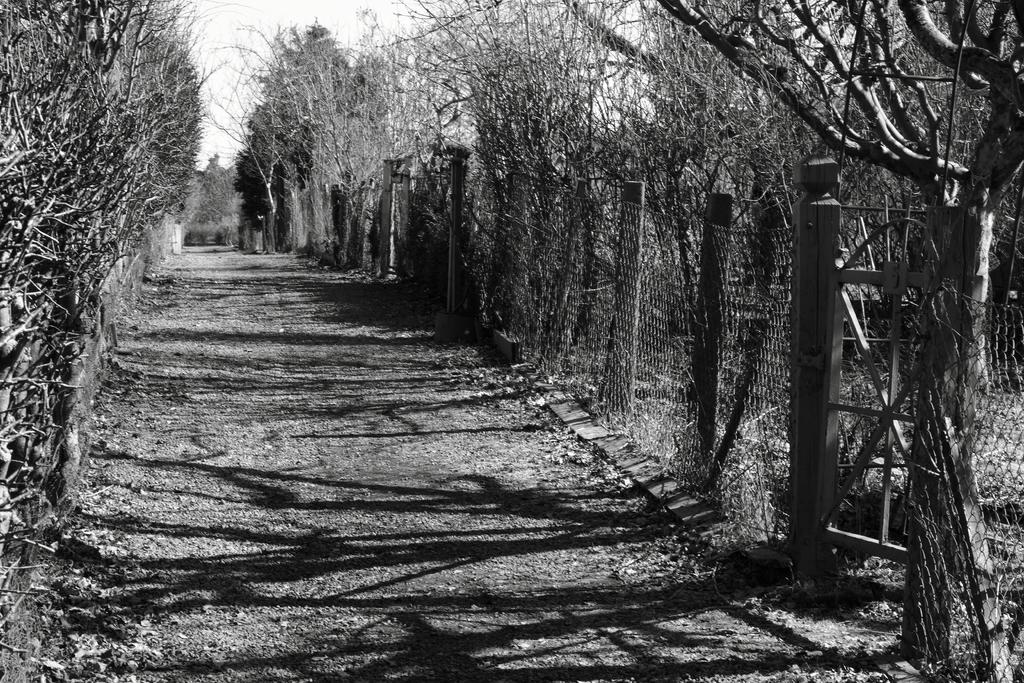What is the color scheme of the image? The image is black and white. What type of structure can be seen in the image? There is a fence and a gate in the image. What type of vegetation is present in the image? There are trees with branches and leaves in the image. What type of path is visible in the image? There is a pathway in the image. What hobbies does the girl in the image enjoy? There is no girl present in the image, so we cannot determine her hobbies. How many curves can be seen in the pathway in the image? The pathway in the image is not described as having any curves, so we cannot determine the number of curves. 